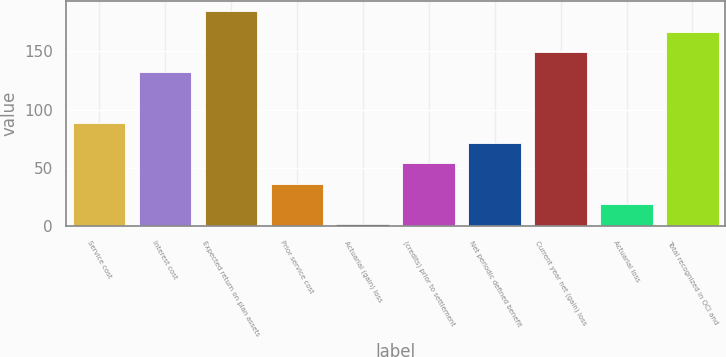<chart> <loc_0><loc_0><loc_500><loc_500><bar_chart><fcel>Service cost<fcel>Interest cost<fcel>Expected return on plan assets<fcel>Prior service cost<fcel>Actuarial (gain) loss<fcel>(credits) prior to settlement<fcel>Net periodic defined benefit<fcel>Current year net (gain) loss<fcel>Actuarial loss<fcel>Total recognized in OCI and<nl><fcel>88.5<fcel>132<fcel>183.9<fcel>36.6<fcel>2<fcel>53.9<fcel>71.2<fcel>149.3<fcel>19.3<fcel>166.6<nl></chart> 